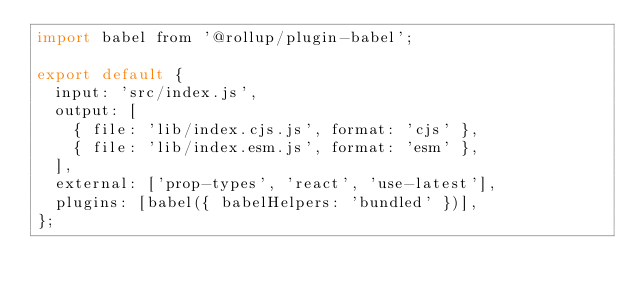Convert code to text. <code><loc_0><loc_0><loc_500><loc_500><_JavaScript_>import babel from '@rollup/plugin-babel';

export default {
  input: 'src/index.js',
  output: [
    { file: 'lib/index.cjs.js', format: 'cjs' },
    { file: 'lib/index.esm.js', format: 'esm' },
  ],
  external: ['prop-types', 'react', 'use-latest'],
  plugins: [babel({ babelHelpers: 'bundled' })],
};
</code> 